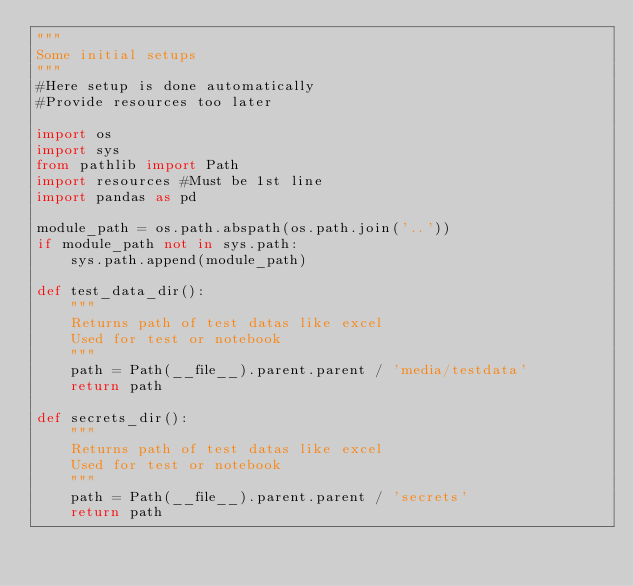Convert code to text. <code><loc_0><loc_0><loc_500><loc_500><_Python_>"""
Some initial setups
"""
#Here setup is done automatically
#Provide resources too later

import os
import sys
from pathlib import Path
import resources #Must be 1st line
import pandas as pd

module_path = os.path.abspath(os.path.join('..'))
if module_path not in sys.path:
    sys.path.append(module_path)

def test_data_dir():
    """
    Returns path of test datas like excel
    Used for test or notebook
    """
    path = Path(__file__).parent.parent / 'media/testdata'
    return path

def secrets_dir():
    """
    Returns path of test datas like excel
    Used for test or notebook
    """
    path = Path(__file__).parent.parent / 'secrets'
    return path</code> 